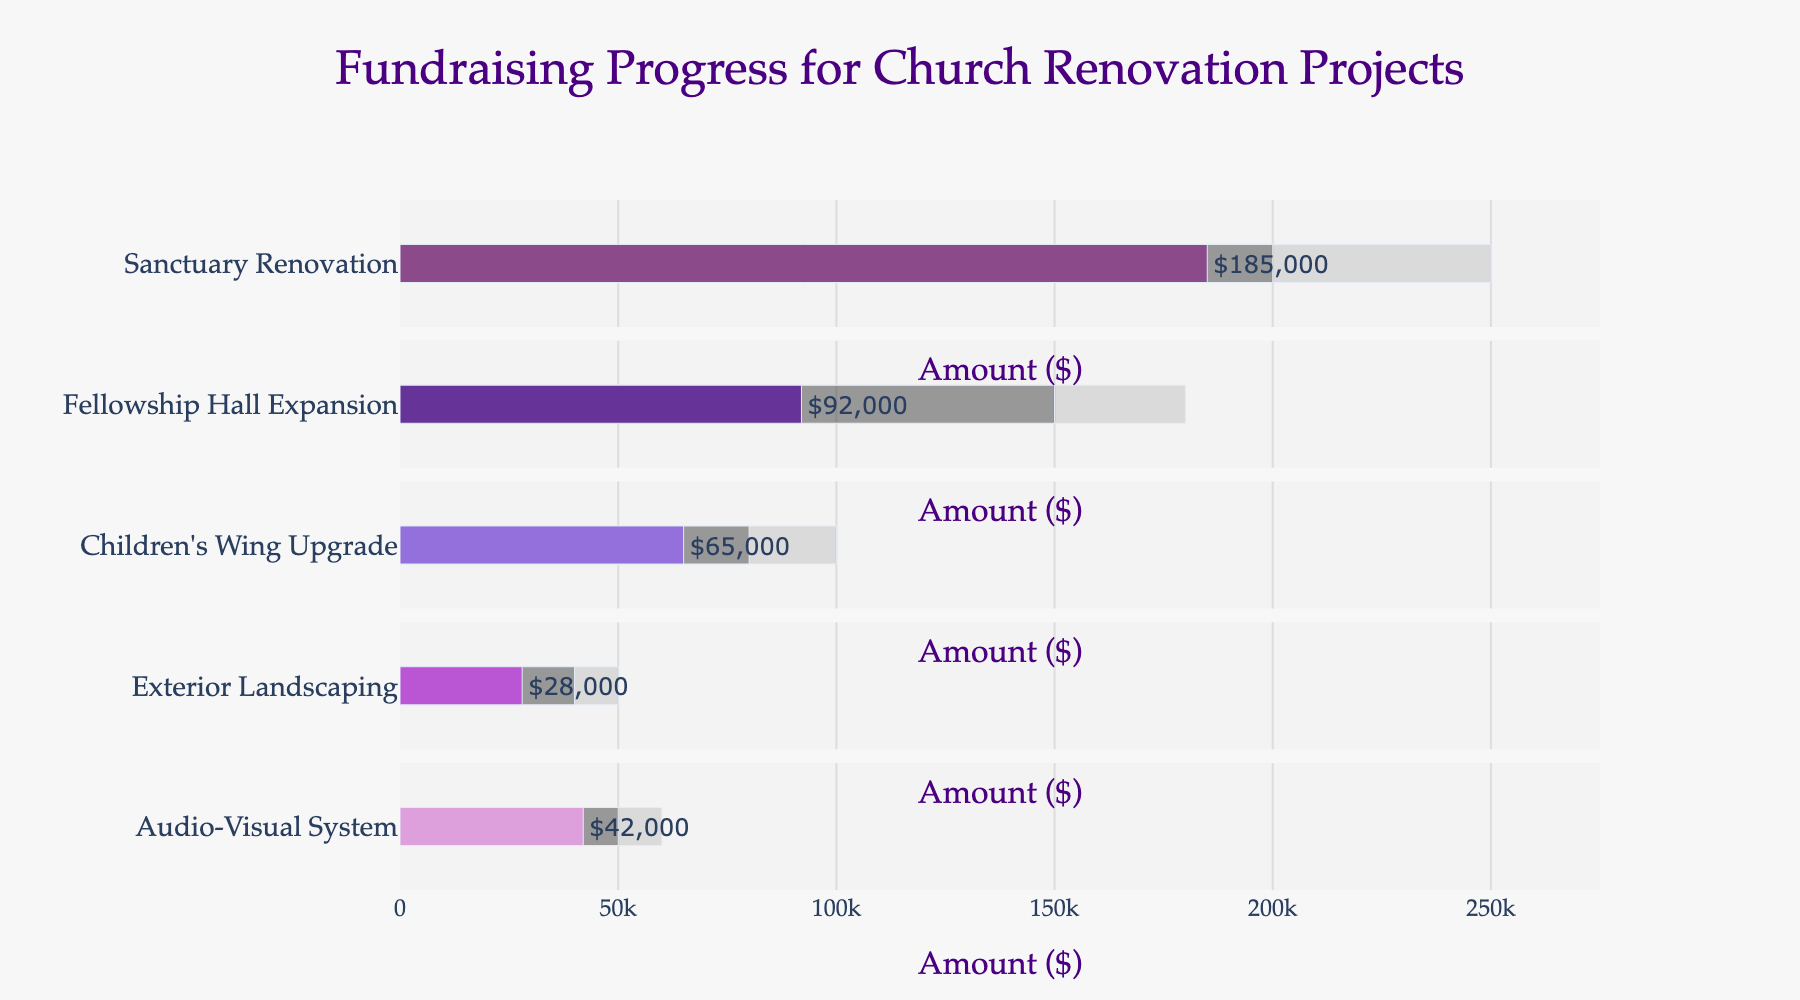How much have we actually raised for the Sanctuary Renovation? The bar labeled 'Sanctuary Renovation' in the plot shows the actual amount raised.
Answer: 185,000 Which phase has the closest actual amount raised to its target? Comparing the actual and target amounts for each phase, the 'Children's Wing Upgrade' has 65,000 raised against an 80,000 target, which is the closest percentage-wise.
Answer: Children's Wing Upgrade What is the combined target amount for all phases? Sum the target amounts from all phases: 200,000 (Sanctuary) + 150,000 (Fellowship Hall) + 80,000 (Children's Wing) + 40,000 (Exterior Landscaping) + 50,000 (Audio-Visual) = 520,000.
Answer: 520,000 Which phase has the largest gap between the actual raised amount and the maximum possible amount? The gaps are calculated as (Maximum - Actual) for each phase. The largest gap is for 'Fellowship Hall Expansion' with a gap of 180,000 - 92,000 = 88,000.
Answer: Fellowship Hall Expansion How much more do we need to reach the target for the Audio-Visual System? Subtract the actual amount from the target amount for the Audio-Visual System: 50,000 - 42,000 = 8,000.
Answer: 8,000 Which phases have reached more than 50% of their target amounts? Calculate 50% of the target for each phase and compare it with the actual amounts. 'Sanctuary Renovation', 'Children's Wing Upgrade', and 'Audio-Visual System' have raised more than 50% of their targets.
Answer: Sanctuary Renovation, Children's Wing Upgrade, Audio-Visual System In which phase is the fundraising progress furthest behind relative to the target? The phase with the smallest ratio of the actual amount raised to its target is 'Fellowship Hall Expansion' (92,000 out of 150,000).
Answer: Fellowship Hall Expansion What's the total actual amount raised across all phases? Sum the actual amounts of all phases: 185,000 (Sanctuary) + 92,000 (Fellowship Hall) + 65,000 (Children's Wing) + 28,000 (Exterior Landscaping) + 42,000 (Audio-Visual) = 412,000.
Answer: 412,000 